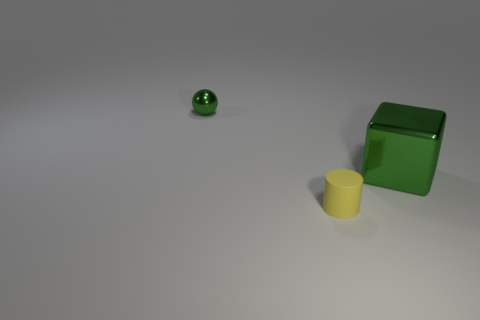There is a cylinder that is the same size as the metal ball; what is its color?
Keep it short and to the point. Yellow. Is the number of matte cylinders that are on the right side of the small rubber object the same as the number of yellow cylinders on the left side of the big green shiny cube?
Offer a terse response. No. Is there a yellow shiny block of the same size as the matte cylinder?
Make the answer very short. No. The cylinder is what size?
Ensure brevity in your answer.  Small. Is the number of green cubes that are in front of the tiny rubber thing the same as the number of green cubes?
Your response must be concise. No. How many other objects are there of the same color as the small metallic ball?
Provide a short and direct response. 1. There is a thing that is on the left side of the green shiny block and behind the small rubber cylinder; what color is it?
Your answer should be compact. Green. There is a green object on the right side of the small object in front of the green metallic sphere that is on the left side of the big green shiny object; what size is it?
Give a very brief answer. Large. What number of objects are objects that are to the left of the tiny matte object or metal objects in front of the green metal ball?
Offer a very short reply. 2. What is the shape of the yellow rubber object?
Make the answer very short. Cylinder. 